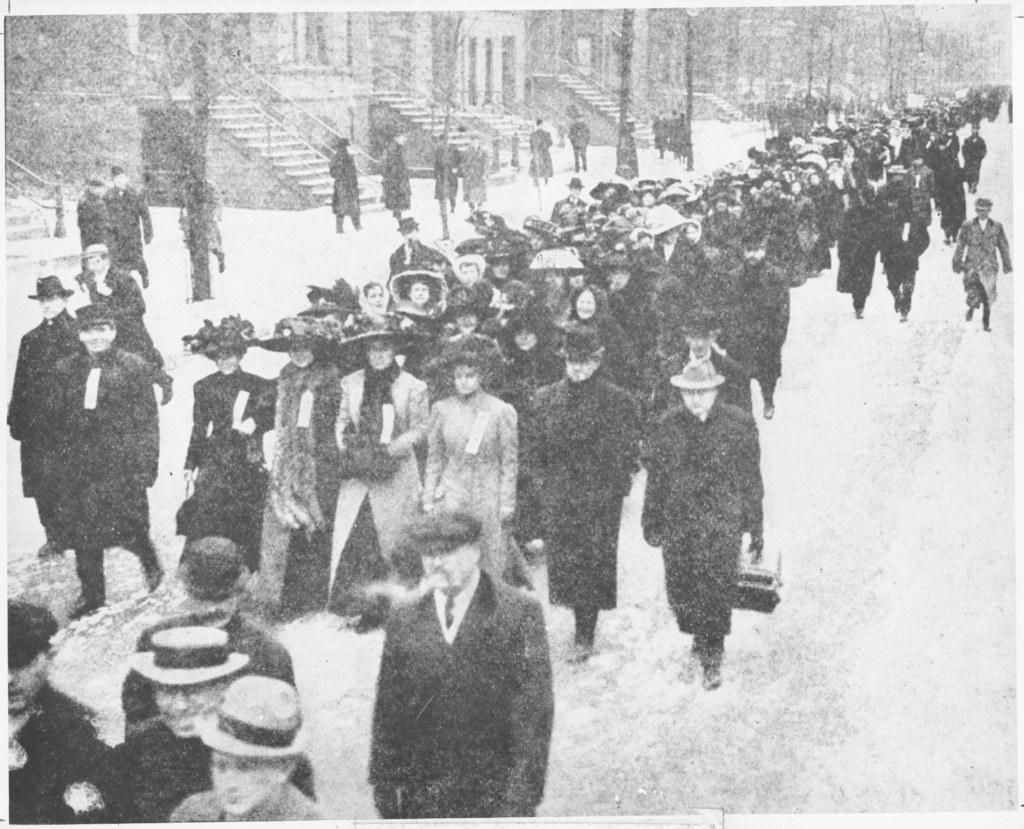What are the people in the image doing? There is a group of people walking on the road in the image. What can be seen on the left side of the image? There are buildings on the left side of the image. What type of natural elements are present in the image? There are trees in the image. What feature can be seen beside the staircases? There are handrails beside the staircases in the image. How does the fear of heights affect the people walking on the road in the image? There is no indication of fear or heights in the image; it simply shows a group of people walking on a road. 